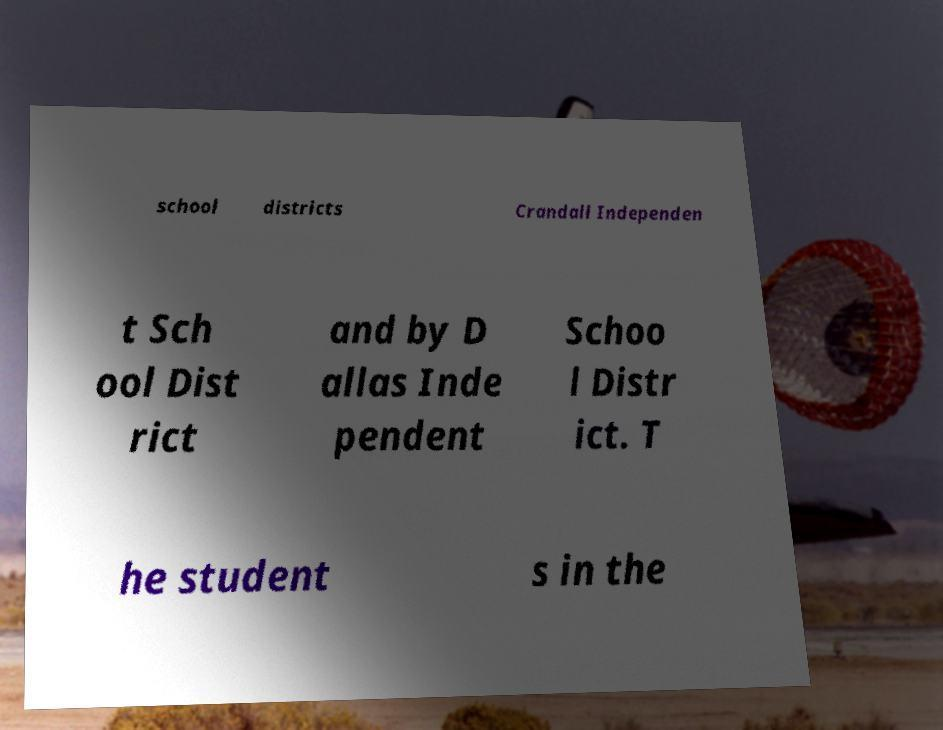Could you extract and type out the text from this image? school districts Crandall Independen t Sch ool Dist rict and by D allas Inde pendent Schoo l Distr ict. T he student s in the 